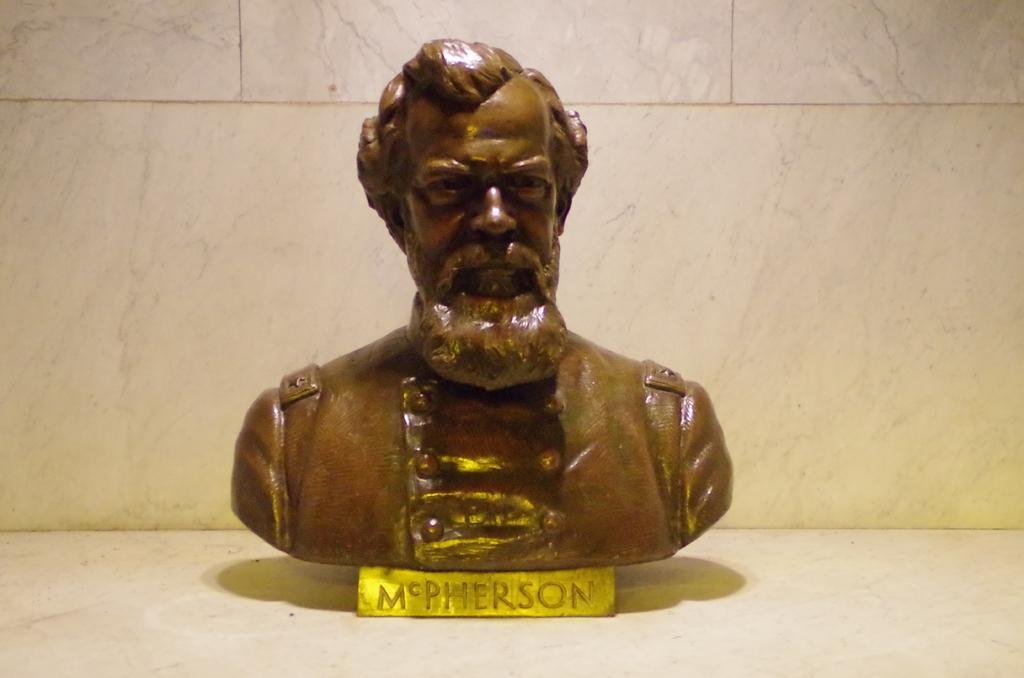Could you give a brief overview of what you see in this image? Here we can see a statue of human on the surface. Background we can see wall. 